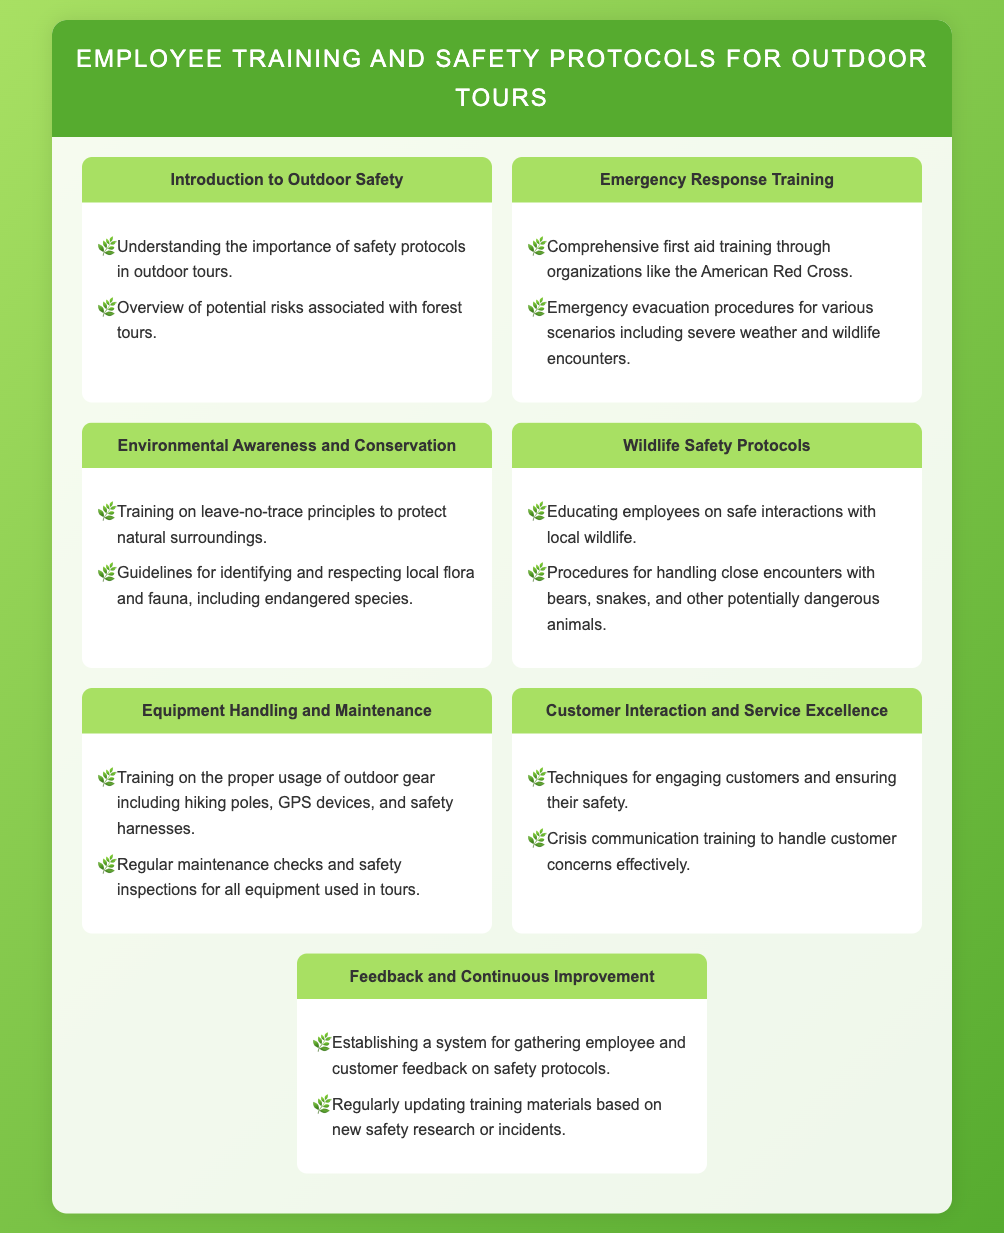what is the title of the document? The title is listed at the top of the rendered document, which is "Employee Training and Safety Protocols for Outdoor Tours."
Answer: Employee Training and Safety Protocols for Outdoor Tours how many sections are there in the menu? The number of sections can be counted from the document, there are seven sections listed.
Answer: 7 what organization provides first aid training? The document mentions the American Red Cross as the organization for first aid training.
Answer: American Red Cross what principle is emphasized for environmental awareness? The document highlights the importance of "leave-no-trace principles" related to environmental awareness.
Answer: leave-no-trace principles what training is provided for customer interaction? The document specifies "Crisis communication training" related to customer interaction and service excellence.
Answer: Crisis communication training which section discusses wildlife interactions? The section titled "Wildlife Safety Protocols" addresses wildlife interactions and safety protocols.
Answer: Wildlife Safety Protocols what is emphasized under Equipment Handling? The document indicates "proper usage of outdoor gear" is emphasized under Equipment Handling and Maintenance.
Answer: proper usage of outdoor gear how often should safety inspection checks occur? The document refers to "regular maintenance checks and safety inspections," indicating ongoing practices.
Answer: Regularly 